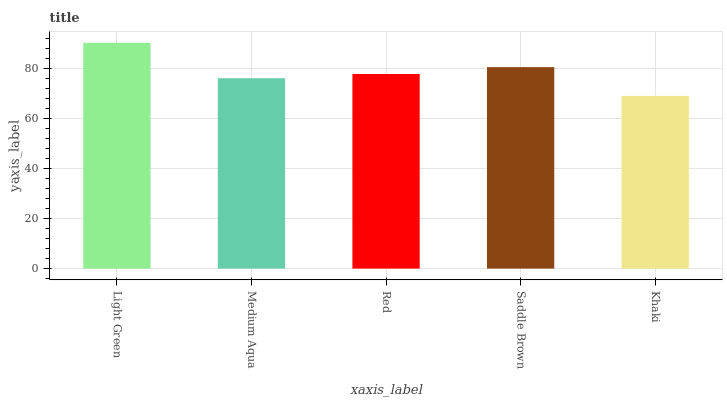Is Khaki the minimum?
Answer yes or no. Yes. Is Light Green the maximum?
Answer yes or no. Yes. Is Medium Aqua the minimum?
Answer yes or no. No. Is Medium Aqua the maximum?
Answer yes or no. No. Is Light Green greater than Medium Aqua?
Answer yes or no. Yes. Is Medium Aqua less than Light Green?
Answer yes or no. Yes. Is Medium Aqua greater than Light Green?
Answer yes or no. No. Is Light Green less than Medium Aqua?
Answer yes or no. No. Is Red the high median?
Answer yes or no. Yes. Is Red the low median?
Answer yes or no. Yes. Is Light Green the high median?
Answer yes or no. No. Is Saddle Brown the low median?
Answer yes or no. No. 